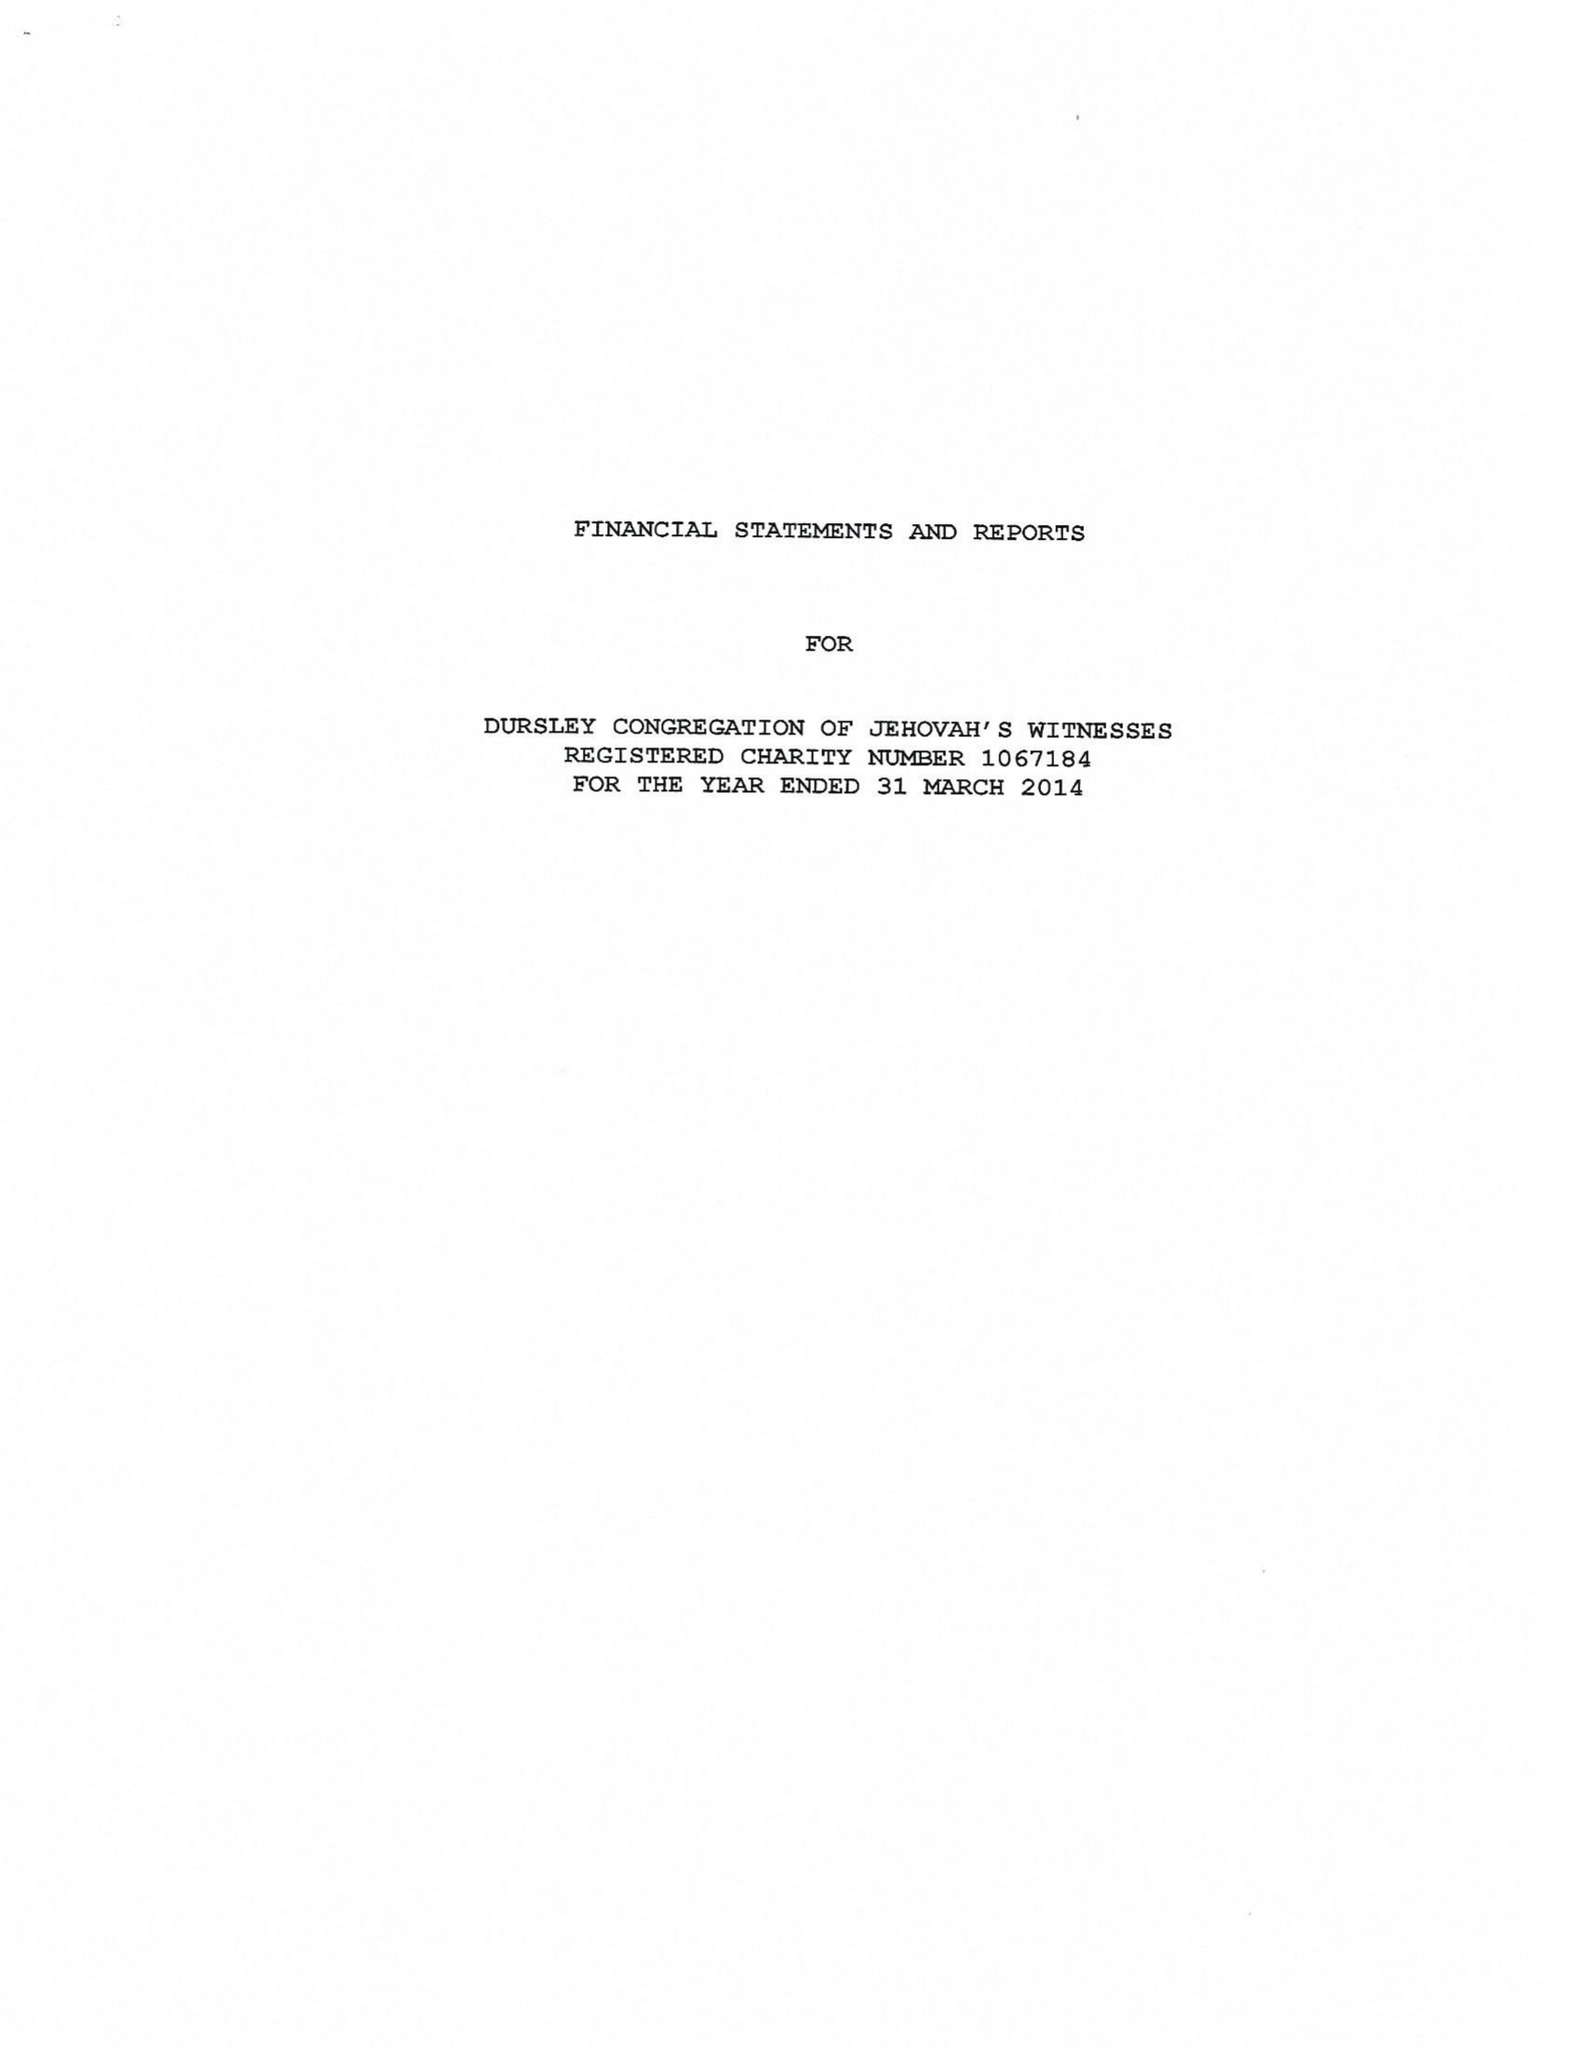What is the value for the report_date?
Answer the question using a single word or phrase. 2014-03-31 